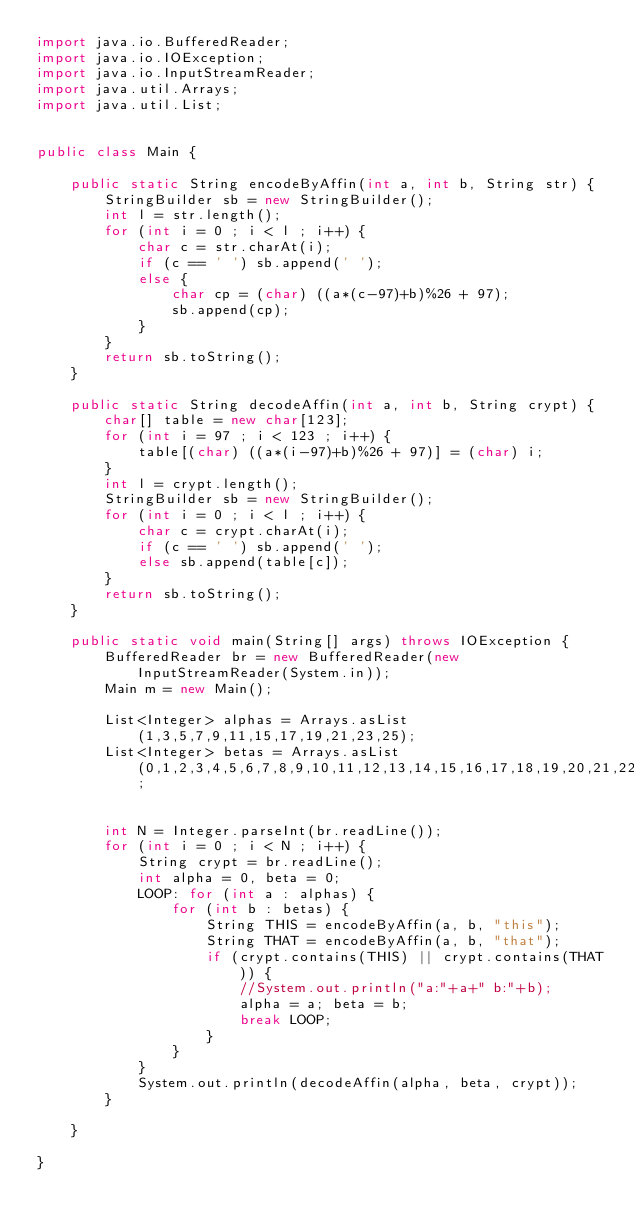Convert code to text. <code><loc_0><loc_0><loc_500><loc_500><_Java_>import java.io.BufferedReader;
import java.io.IOException;
import java.io.InputStreamReader;
import java.util.Arrays;
import java.util.List;


public class Main {

	public static String encodeByAffin(int a, int b, String str) {
		StringBuilder sb = new StringBuilder();
		int l = str.length();
		for (int i = 0 ; i < l ; i++) {
			char c = str.charAt(i);
			if (c == ' ') sb.append(' ');
			else {
				char cp = (char) ((a*(c-97)+b)%26 + 97);
				sb.append(cp);
			}
		}
		return sb.toString();
	}

	public static String decodeAffin(int a, int b, String crypt) {
		char[] table = new char[123];
		for (int i = 97 ; i < 123 ; i++) {
			table[(char) ((a*(i-97)+b)%26 + 97)] = (char) i;
		}
		int l = crypt.length();
		StringBuilder sb = new StringBuilder();
		for (int i = 0 ; i < l ; i++) {
			char c = crypt.charAt(i);
			if (c == ' ') sb.append(' ');
			else sb.append(table[c]);
		}
		return sb.toString();
	}

	public static void main(String[] args) throws IOException {
		BufferedReader br = new BufferedReader(new InputStreamReader(System.in));
		Main m = new Main();

		List<Integer> alphas = Arrays.asList(1,3,5,7,9,11,15,17,19,21,23,25);
		List<Integer> betas = Arrays.asList(0,1,2,3,4,5,6,7,8,9,10,11,12,13,14,15,16,17,18,19,20,21,22,23,24,25);


		int N = Integer.parseInt(br.readLine());
		for (int i = 0 ; i < N ; i++) {
			String crypt = br.readLine();
			int alpha = 0, beta = 0;
			LOOP: for (int a : alphas) {
				for (int b : betas) {
					String THIS = encodeByAffin(a, b, "this");
					String THAT = encodeByAffin(a, b, "that");
					if (crypt.contains(THIS) || crypt.contains(THAT)) {
						//System.out.println("a:"+a+" b:"+b);
						alpha = a; beta = b;
						break LOOP;
					}
				}
			}
			System.out.println(decodeAffin(alpha, beta, crypt));
		}

	}

}</code> 